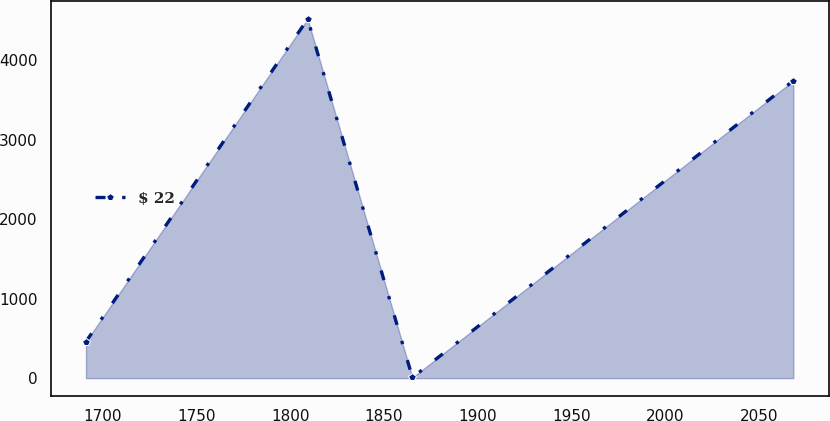Convert chart to OTSL. <chart><loc_0><loc_0><loc_500><loc_500><line_chart><ecel><fcel>$ 22<nl><fcel>1691.2<fcel>458.81<nl><fcel>1809.34<fcel>4516.57<nl><fcel>1865.15<fcel>7.95<nl><fcel>2068.11<fcel>3740.46<nl></chart> 